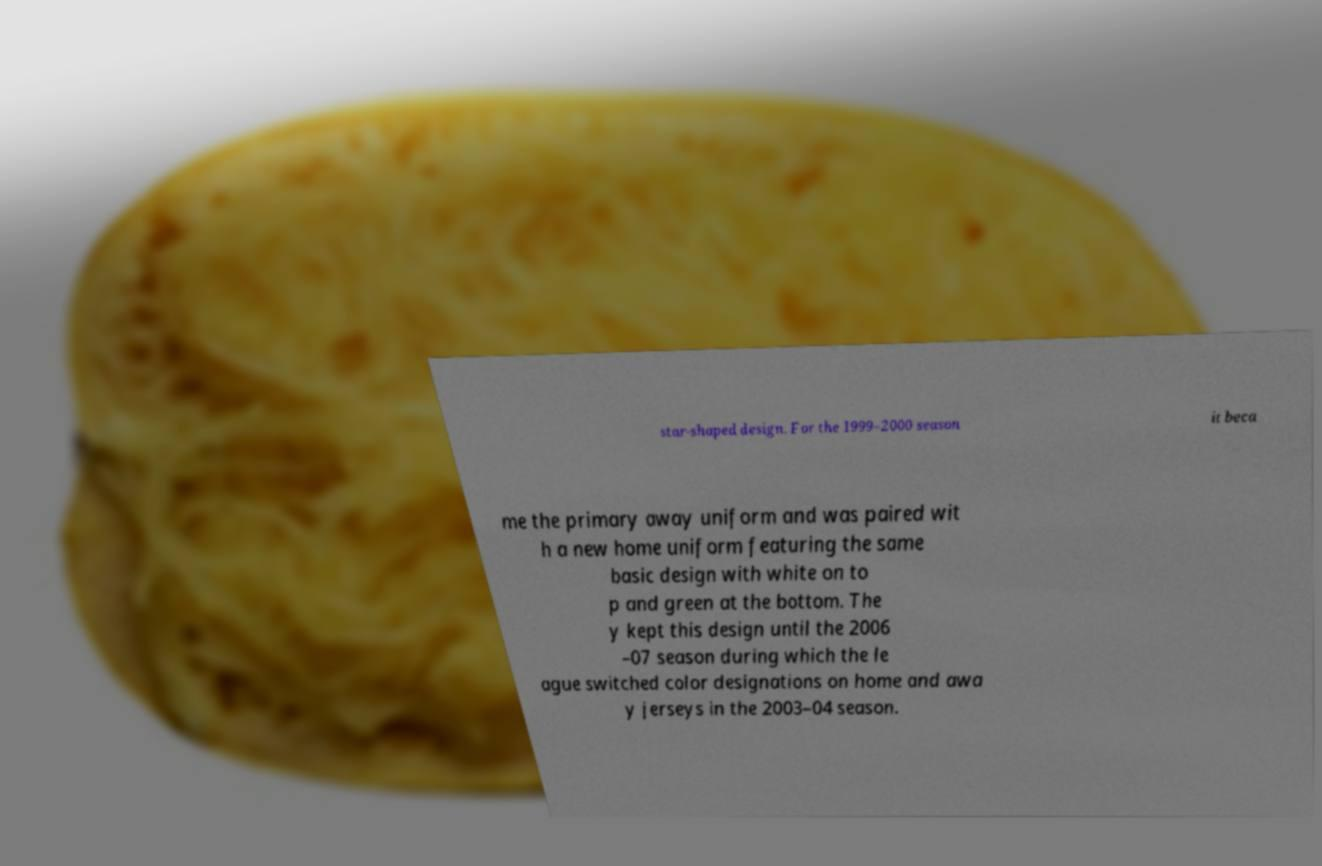For documentation purposes, I need the text within this image transcribed. Could you provide that? star-shaped design. For the 1999–2000 season it beca me the primary away uniform and was paired wit h a new home uniform featuring the same basic design with white on to p and green at the bottom. The y kept this design until the 2006 –07 season during which the le ague switched color designations on home and awa y jerseys in the 2003–04 season. 